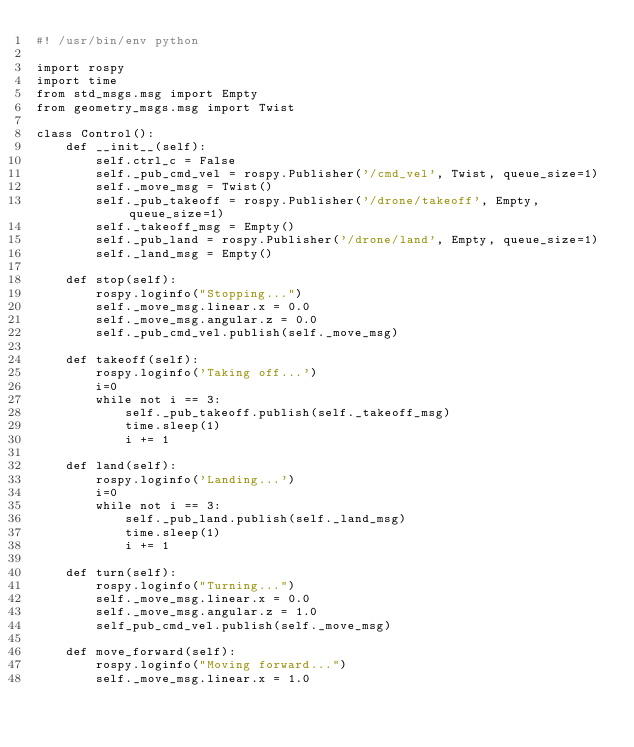<code> <loc_0><loc_0><loc_500><loc_500><_Python_>#! /usr/bin/env python

import rospy
import time
from std_msgs.msg import Empty
from geometry_msgs.msg import Twist

class Control():
    def __init__(self):
        self.ctrl_c = False
        self._pub_cmd_vel = rospy.Publisher('/cmd_vel', Twist, queue_size=1)
        self._move_msg = Twist()
        self._pub_takeoff = rospy.Publisher('/drone/takeoff', Empty, queue_size=1)
        self._takeoff_msg = Empty()
        self._pub_land = rospy.Publisher('/drone/land', Empty, queue_size=1)
        self._land_msg = Empty()

    def stop(self):
        rospy.loginfo("Stopping...")
        self._move_msg.linear.x = 0.0
        self._move_msg.angular.z = 0.0
        self._pub_cmd_vel.publish(self._move_msg)

    def takeoff(self):
        rospy.loginfo('Taking off...')
        i=0
        while not i == 3:
            self._pub_takeoff.publish(self._takeoff_msg)
            time.sleep(1)
            i += 1
    
    def land(self):
        rospy.loginfo('Landing...')
        i=0
        while not i == 3:
            self._pub_land.publish(self._land_msg)
            time.sleep(1)
            i += 1

    def turn(self):
        rospy.loginfo("Turning...")
        self._move_msg.linear.x = 0.0
        self._move_msg.angular.z = 1.0
        self_pub_cmd_vel.publish(self._move_msg)

    def move_forward(self):
        rospy.loginfo("Moving forward...")
        self._move_msg.linear.x = 1.0</code> 